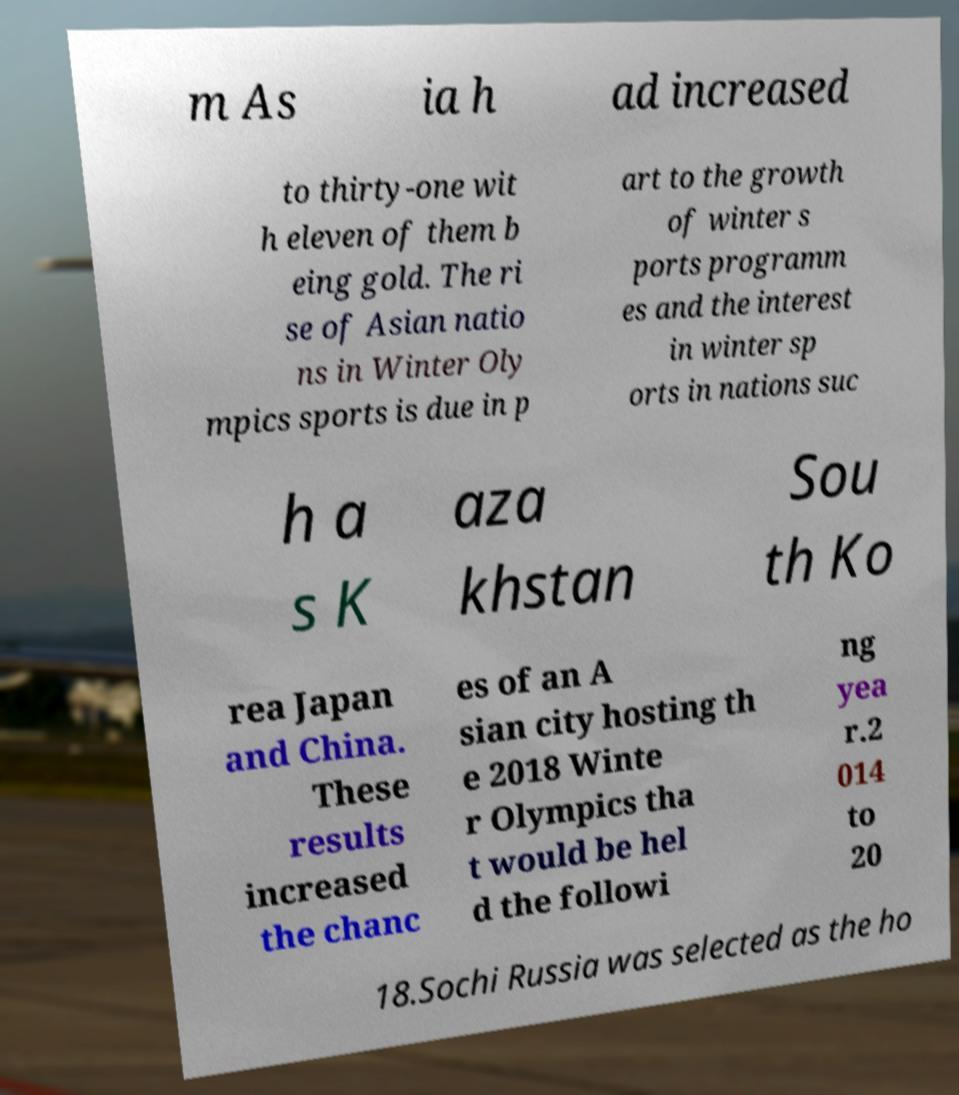What messages or text are displayed in this image? I need them in a readable, typed format. m As ia h ad increased to thirty-one wit h eleven of them b eing gold. The ri se of Asian natio ns in Winter Oly mpics sports is due in p art to the growth of winter s ports programm es and the interest in winter sp orts in nations suc h a s K aza khstan Sou th Ko rea Japan and China. These results increased the chanc es of an A sian city hosting th e 2018 Winte r Olympics tha t would be hel d the followi ng yea r.2 014 to 20 18.Sochi Russia was selected as the ho 